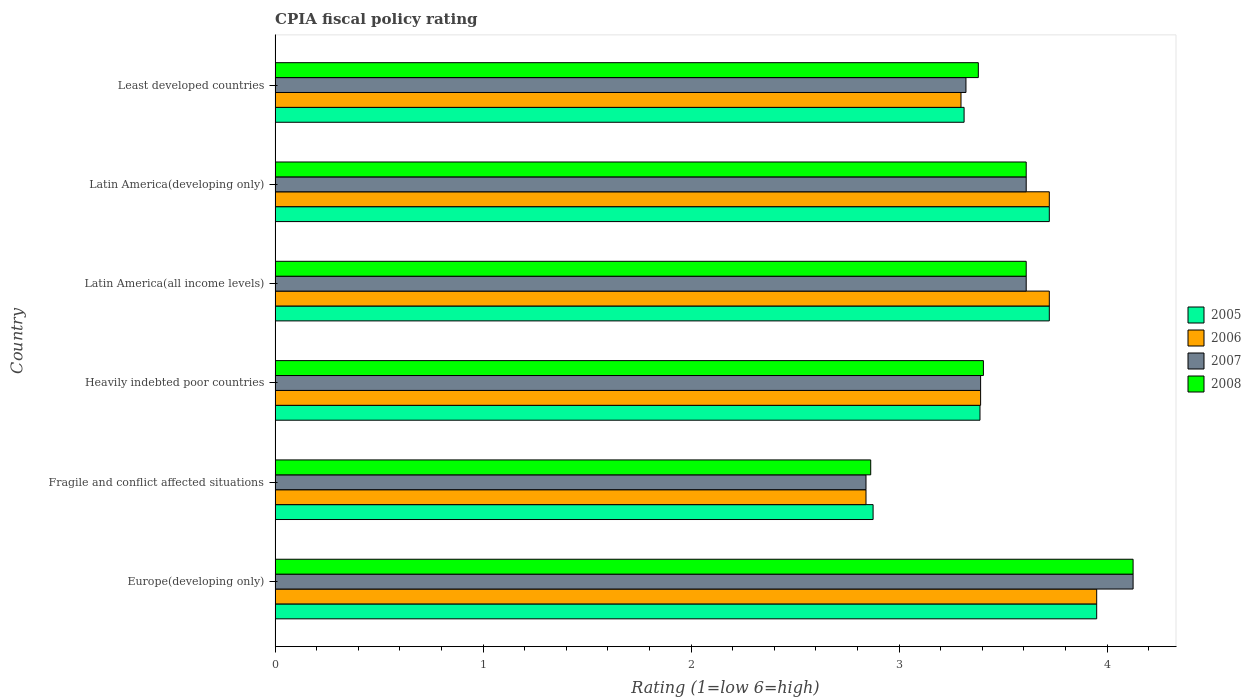How many different coloured bars are there?
Make the answer very short. 4. How many groups of bars are there?
Keep it short and to the point. 6. How many bars are there on the 3rd tick from the top?
Your response must be concise. 4. How many bars are there on the 5th tick from the bottom?
Ensure brevity in your answer.  4. What is the label of the 1st group of bars from the top?
Provide a short and direct response. Least developed countries. What is the CPIA rating in 2007 in Latin America(developing only)?
Ensure brevity in your answer.  3.61. Across all countries, what is the maximum CPIA rating in 2008?
Provide a succinct answer. 4.12. Across all countries, what is the minimum CPIA rating in 2006?
Your answer should be compact. 2.84. In which country was the CPIA rating in 2005 maximum?
Ensure brevity in your answer.  Europe(developing only). In which country was the CPIA rating in 2008 minimum?
Provide a short and direct response. Fragile and conflict affected situations. What is the total CPIA rating in 2005 in the graph?
Give a very brief answer. 20.97. What is the difference between the CPIA rating in 2006 in Latin America(all income levels) and that in Least developed countries?
Your answer should be compact. 0.42. What is the difference between the CPIA rating in 2005 in Heavily indebted poor countries and the CPIA rating in 2006 in Latin America(developing only)?
Provide a short and direct response. -0.33. What is the average CPIA rating in 2007 per country?
Your answer should be compact. 3.48. What is the difference between the CPIA rating in 2008 and CPIA rating in 2007 in Fragile and conflict affected situations?
Make the answer very short. 0.02. What is the ratio of the CPIA rating in 2007 in Europe(developing only) to that in Least developed countries?
Provide a short and direct response. 1.24. Is the difference between the CPIA rating in 2008 in Europe(developing only) and Heavily indebted poor countries greater than the difference between the CPIA rating in 2007 in Europe(developing only) and Heavily indebted poor countries?
Ensure brevity in your answer.  No. What is the difference between the highest and the second highest CPIA rating in 2005?
Keep it short and to the point. 0.23. What is the difference between the highest and the lowest CPIA rating in 2006?
Your response must be concise. 1.11. Is it the case that in every country, the sum of the CPIA rating in 2006 and CPIA rating in 2005 is greater than the CPIA rating in 2008?
Ensure brevity in your answer.  Yes. How many bars are there?
Ensure brevity in your answer.  24. How many countries are there in the graph?
Give a very brief answer. 6. What is the difference between two consecutive major ticks on the X-axis?
Offer a very short reply. 1. Are the values on the major ticks of X-axis written in scientific E-notation?
Offer a very short reply. No. What is the title of the graph?
Offer a terse response. CPIA fiscal policy rating. Does "1997" appear as one of the legend labels in the graph?
Give a very brief answer. No. What is the label or title of the X-axis?
Your answer should be very brief. Rating (1=low 6=high). What is the label or title of the Y-axis?
Provide a succinct answer. Country. What is the Rating (1=low 6=high) of 2005 in Europe(developing only)?
Your answer should be compact. 3.95. What is the Rating (1=low 6=high) in 2006 in Europe(developing only)?
Ensure brevity in your answer.  3.95. What is the Rating (1=low 6=high) of 2007 in Europe(developing only)?
Offer a terse response. 4.12. What is the Rating (1=low 6=high) in 2008 in Europe(developing only)?
Keep it short and to the point. 4.12. What is the Rating (1=low 6=high) of 2005 in Fragile and conflict affected situations?
Provide a succinct answer. 2.88. What is the Rating (1=low 6=high) in 2006 in Fragile and conflict affected situations?
Offer a very short reply. 2.84. What is the Rating (1=low 6=high) of 2007 in Fragile and conflict affected situations?
Offer a terse response. 2.84. What is the Rating (1=low 6=high) in 2008 in Fragile and conflict affected situations?
Provide a succinct answer. 2.86. What is the Rating (1=low 6=high) in 2005 in Heavily indebted poor countries?
Keep it short and to the point. 3.39. What is the Rating (1=low 6=high) in 2006 in Heavily indebted poor countries?
Your response must be concise. 3.39. What is the Rating (1=low 6=high) in 2007 in Heavily indebted poor countries?
Keep it short and to the point. 3.39. What is the Rating (1=low 6=high) in 2008 in Heavily indebted poor countries?
Make the answer very short. 3.41. What is the Rating (1=low 6=high) in 2005 in Latin America(all income levels)?
Your answer should be compact. 3.72. What is the Rating (1=low 6=high) in 2006 in Latin America(all income levels)?
Ensure brevity in your answer.  3.72. What is the Rating (1=low 6=high) in 2007 in Latin America(all income levels)?
Make the answer very short. 3.61. What is the Rating (1=low 6=high) in 2008 in Latin America(all income levels)?
Offer a terse response. 3.61. What is the Rating (1=low 6=high) in 2005 in Latin America(developing only)?
Keep it short and to the point. 3.72. What is the Rating (1=low 6=high) in 2006 in Latin America(developing only)?
Provide a short and direct response. 3.72. What is the Rating (1=low 6=high) in 2007 in Latin America(developing only)?
Your answer should be very brief. 3.61. What is the Rating (1=low 6=high) in 2008 in Latin America(developing only)?
Your answer should be very brief. 3.61. What is the Rating (1=low 6=high) in 2005 in Least developed countries?
Offer a terse response. 3.31. What is the Rating (1=low 6=high) in 2006 in Least developed countries?
Your answer should be very brief. 3.3. What is the Rating (1=low 6=high) of 2007 in Least developed countries?
Give a very brief answer. 3.32. What is the Rating (1=low 6=high) of 2008 in Least developed countries?
Provide a short and direct response. 3.38. Across all countries, what is the maximum Rating (1=low 6=high) in 2005?
Provide a succinct answer. 3.95. Across all countries, what is the maximum Rating (1=low 6=high) in 2006?
Your answer should be very brief. 3.95. Across all countries, what is the maximum Rating (1=low 6=high) of 2007?
Offer a terse response. 4.12. Across all countries, what is the maximum Rating (1=low 6=high) in 2008?
Keep it short and to the point. 4.12. Across all countries, what is the minimum Rating (1=low 6=high) in 2005?
Give a very brief answer. 2.88. Across all countries, what is the minimum Rating (1=low 6=high) of 2006?
Ensure brevity in your answer.  2.84. Across all countries, what is the minimum Rating (1=low 6=high) in 2007?
Make the answer very short. 2.84. Across all countries, what is the minimum Rating (1=low 6=high) in 2008?
Provide a succinct answer. 2.86. What is the total Rating (1=low 6=high) in 2005 in the graph?
Make the answer very short. 20.97. What is the total Rating (1=low 6=high) in 2006 in the graph?
Make the answer very short. 20.92. What is the total Rating (1=low 6=high) in 2007 in the graph?
Provide a succinct answer. 20.9. What is the total Rating (1=low 6=high) of 2008 in the graph?
Offer a very short reply. 21. What is the difference between the Rating (1=low 6=high) in 2005 in Europe(developing only) and that in Fragile and conflict affected situations?
Your response must be concise. 1.07. What is the difference between the Rating (1=low 6=high) of 2006 in Europe(developing only) and that in Fragile and conflict affected situations?
Your answer should be compact. 1.11. What is the difference between the Rating (1=low 6=high) of 2007 in Europe(developing only) and that in Fragile and conflict affected situations?
Your response must be concise. 1.28. What is the difference between the Rating (1=low 6=high) in 2008 in Europe(developing only) and that in Fragile and conflict affected situations?
Keep it short and to the point. 1.26. What is the difference between the Rating (1=low 6=high) in 2005 in Europe(developing only) and that in Heavily indebted poor countries?
Offer a very short reply. 0.56. What is the difference between the Rating (1=low 6=high) of 2006 in Europe(developing only) and that in Heavily indebted poor countries?
Make the answer very short. 0.56. What is the difference between the Rating (1=low 6=high) of 2007 in Europe(developing only) and that in Heavily indebted poor countries?
Offer a terse response. 0.73. What is the difference between the Rating (1=low 6=high) in 2008 in Europe(developing only) and that in Heavily indebted poor countries?
Ensure brevity in your answer.  0.72. What is the difference between the Rating (1=low 6=high) of 2005 in Europe(developing only) and that in Latin America(all income levels)?
Make the answer very short. 0.23. What is the difference between the Rating (1=low 6=high) in 2006 in Europe(developing only) and that in Latin America(all income levels)?
Offer a very short reply. 0.23. What is the difference between the Rating (1=low 6=high) in 2007 in Europe(developing only) and that in Latin America(all income levels)?
Provide a short and direct response. 0.51. What is the difference between the Rating (1=low 6=high) of 2008 in Europe(developing only) and that in Latin America(all income levels)?
Your answer should be very brief. 0.51. What is the difference between the Rating (1=low 6=high) in 2005 in Europe(developing only) and that in Latin America(developing only)?
Ensure brevity in your answer.  0.23. What is the difference between the Rating (1=low 6=high) in 2006 in Europe(developing only) and that in Latin America(developing only)?
Your response must be concise. 0.23. What is the difference between the Rating (1=low 6=high) of 2007 in Europe(developing only) and that in Latin America(developing only)?
Make the answer very short. 0.51. What is the difference between the Rating (1=low 6=high) in 2008 in Europe(developing only) and that in Latin America(developing only)?
Offer a terse response. 0.51. What is the difference between the Rating (1=low 6=high) of 2005 in Europe(developing only) and that in Least developed countries?
Offer a terse response. 0.64. What is the difference between the Rating (1=low 6=high) of 2006 in Europe(developing only) and that in Least developed countries?
Ensure brevity in your answer.  0.65. What is the difference between the Rating (1=low 6=high) in 2007 in Europe(developing only) and that in Least developed countries?
Your answer should be compact. 0.8. What is the difference between the Rating (1=low 6=high) in 2008 in Europe(developing only) and that in Least developed countries?
Your answer should be compact. 0.74. What is the difference between the Rating (1=low 6=high) in 2005 in Fragile and conflict affected situations and that in Heavily indebted poor countries?
Your response must be concise. -0.51. What is the difference between the Rating (1=low 6=high) in 2006 in Fragile and conflict affected situations and that in Heavily indebted poor countries?
Offer a terse response. -0.55. What is the difference between the Rating (1=low 6=high) in 2007 in Fragile and conflict affected situations and that in Heavily indebted poor countries?
Your answer should be very brief. -0.55. What is the difference between the Rating (1=low 6=high) of 2008 in Fragile and conflict affected situations and that in Heavily indebted poor countries?
Your response must be concise. -0.54. What is the difference between the Rating (1=low 6=high) of 2005 in Fragile and conflict affected situations and that in Latin America(all income levels)?
Your response must be concise. -0.85. What is the difference between the Rating (1=low 6=high) in 2006 in Fragile and conflict affected situations and that in Latin America(all income levels)?
Offer a very short reply. -0.88. What is the difference between the Rating (1=low 6=high) of 2007 in Fragile and conflict affected situations and that in Latin America(all income levels)?
Your answer should be compact. -0.77. What is the difference between the Rating (1=low 6=high) of 2008 in Fragile and conflict affected situations and that in Latin America(all income levels)?
Make the answer very short. -0.75. What is the difference between the Rating (1=low 6=high) of 2005 in Fragile and conflict affected situations and that in Latin America(developing only)?
Offer a terse response. -0.85. What is the difference between the Rating (1=low 6=high) of 2006 in Fragile and conflict affected situations and that in Latin America(developing only)?
Give a very brief answer. -0.88. What is the difference between the Rating (1=low 6=high) of 2007 in Fragile and conflict affected situations and that in Latin America(developing only)?
Provide a succinct answer. -0.77. What is the difference between the Rating (1=low 6=high) of 2008 in Fragile and conflict affected situations and that in Latin America(developing only)?
Ensure brevity in your answer.  -0.75. What is the difference between the Rating (1=low 6=high) of 2005 in Fragile and conflict affected situations and that in Least developed countries?
Give a very brief answer. -0.44. What is the difference between the Rating (1=low 6=high) of 2006 in Fragile and conflict affected situations and that in Least developed countries?
Ensure brevity in your answer.  -0.46. What is the difference between the Rating (1=low 6=high) in 2007 in Fragile and conflict affected situations and that in Least developed countries?
Make the answer very short. -0.48. What is the difference between the Rating (1=low 6=high) in 2008 in Fragile and conflict affected situations and that in Least developed countries?
Give a very brief answer. -0.52. What is the difference between the Rating (1=low 6=high) in 2005 in Heavily indebted poor countries and that in Latin America(all income levels)?
Keep it short and to the point. -0.33. What is the difference between the Rating (1=low 6=high) in 2006 in Heavily indebted poor countries and that in Latin America(all income levels)?
Make the answer very short. -0.33. What is the difference between the Rating (1=low 6=high) of 2007 in Heavily indebted poor countries and that in Latin America(all income levels)?
Keep it short and to the point. -0.22. What is the difference between the Rating (1=low 6=high) in 2008 in Heavily indebted poor countries and that in Latin America(all income levels)?
Offer a terse response. -0.21. What is the difference between the Rating (1=low 6=high) of 2005 in Heavily indebted poor countries and that in Latin America(developing only)?
Ensure brevity in your answer.  -0.33. What is the difference between the Rating (1=low 6=high) in 2006 in Heavily indebted poor countries and that in Latin America(developing only)?
Give a very brief answer. -0.33. What is the difference between the Rating (1=low 6=high) in 2007 in Heavily indebted poor countries and that in Latin America(developing only)?
Provide a succinct answer. -0.22. What is the difference between the Rating (1=low 6=high) in 2008 in Heavily indebted poor countries and that in Latin America(developing only)?
Provide a succinct answer. -0.21. What is the difference between the Rating (1=low 6=high) in 2005 in Heavily indebted poor countries and that in Least developed countries?
Your response must be concise. 0.08. What is the difference between the Rating (1=low 6=high) in 2006 in Heavily indebted poor countries and that in Least developed countries?
Keep it short and to the point. 0.09. What is the difference between the Rating (1=low 6=high) of 2007 in Heavily indebted poor countries and that in Least developed countries?
Offer a very short reply. 0.07. What is the difference between the Rating (1=low 6=high) in 2008 in Heavily indebted poor countries and that in Least developed countries?
Your answer should be compact. 0.02. What is the difference between the Rating (1=low 6=high) of 2006 in Latin America(all income levels) and that in Latin America(developing only)?
Offer a very short reply. 0. What is the difference between the Rating (1=low 6=high) in 2007 in Latin America(all income levels) and that in Latin America(developing only)?
Ensure brevity in your answer.  0. What is the difference between the Rating (1=low 6=high) in 2008 in Latin America(all income levels) and that in Latin America(developing only)?
Make the answer very short. 0. What is the difference between the Rating (1=low 6=high) of 2005 in Latin America(all income levels) and that in Least developed countries?
Keep it short and to the point. 0.41. What is the difference between the Rating (1=low 6=high) in 2006 in Latin America(all income levels) and that in Least developed countries?
Offer a very short reply. 0.42. What is the difference between the Rating (1=low 6=high) of 2007 in Latin America(all income levels) and that in Least developed countries?
Keep it short and to the point. 0.29. What is the difference between the Rating (1=low 6=high) of 2008 in Latin America(all income levels) and that in Least developed countries?
Keep it short and to the point. 0.23. What is the difference between the Rating (1=low 6=high) of 2005 in Latin America(developing only) and that in Least developed countries?
Give a very brief answer. 0.41. What is the difference between the Rating (1=low 6=high) in 2006 in Latin America(developing only) and that in Least developed countries?
Your response must be concise. 0.42. What is the difference between the Rating (1=low 6=high) of 2007 in Latin America(developing only) and that in Least developed countries?
Ensure brevity in your answer.  0.29. What is the difference between the Rating (1=low 6=high) of 2008 in Latin America(developing only) and that in Least developed countries?
Your answer should be very brief. 0.23. What is the difference between the Rating (1=low 6=high) of 2005 in Europe(developing only) and the Rating (1=low 6=high) of 2006 in Fragile and conflict affected situations?
Your response must be concise. 1.11. What is the difference between the Rating (1=low 6=high) of 2005 in Europe(developing only) and the Rating (1=low 6=high) of 2007 in Fragile and conflict affected situations?
Your answer should be compact. 1.11. What is the difference between the Rating (1=low 6=high) in 2005 in Europe(developing only) and the Rating (1=low 6=high) in 2008 in Fragile and conflict affected situations?
Ensure brevity in your answer.  1.09. What is the difference between the Rating (1=low 6=high) in 2006 in Europe(developing only) and the Rating (1=low 6=high) in 2007 in Fragile and conflict affected situations?
Provide a succinct answer. 1.11. What is the difference between the Rating (1=low 6=high) of 2006 in Europe(developing only) and the Rating (1=low 6=high) of 2008 in Fragile and conflict affected situations?
Your answer should be compact. 1.09. What is the difference between the Rating (1=low 6=high) of 2007 in Europe(developing only) and the Rating (1=low 6=high) of 2008 in Fragile and conflict affected situations?
Offer a terse response. 1.26. What is the difference between the Rating (1=low 6=high) in 2005 in Europe(developing only) and the Rating (1=low 6=high) in 2006 in Heavily indebted poor countries?
Your answer should be compact. 0.56. What is the difference between the Rating (1=low 6=high) in 2005 in Europe(developing only) and the Rating (1=low 6=high) in 2007 in Heavily indebted poor countries?
Give a very brief answer. 0.56. What is the difference between the Rating (1=low 6=high) in 2005 in Europe(developing only) and the Rating (1=low 6=high) in 2008 in Heavily indebted poor countries?
Keep it short and to the point. 0.54. What is the difference between the Rating (1=low 6=high) of 2006 in Europe(developing only) and the Rating (1=low 6=high) of 2007 in Heavily indebted poor countries?
Make the answer very short. 0.56. What is the difference between the Rating (1=low 6=high) in 2006 in Europe(developing only) and the Rating (1=low 6=high) in 2008 in Heavily indebted poor countries?
Your answer should be very brief. 0.54. What is the difference between the Rating (1=low 6=high) of 2007 in Europe(developing only) and the Rating (1=low 6=high) of 2008 in Heavily indebted poor countries?
Make the answer very short. 0.72. What is the difference between the Rating (1=low 6=high) in 2005 in Europe(developing only) and the Rating (1=low 6=high) in 2006 in Latin America(all income levels)?
Your response must be concise. 0.23. What is the difference between the Rating (1=low 6=high) of 2005 in Europe(developing only) and the Rating (1=low 6=high) of 2007 in Latin America(all income levels)?
Your answer should be very brief. 0.34. What is the difference between the Rating (1=low 6=high) of 2005 in Europe(developing only) and the Rating (1=low 6=high) of 2008 in Latin America(all income levels)?
Provide a short and direct response. 0.34. What is the difference between the Rating (1=low 6=high) in 2006 in Europe(developing only) and the Rating (1=low 6=high) in 2007 in Latin America(all income levels)?
Give a very brief answer. 0.34. What is the difference between the Rating (1=low 6=high) of 2006 in Europe(developing only) and the Rating (1=low 6=high) of 2008 in Latin America(all income levels)?
Keep it short and to the point. 0.34. What is the difference between the Rating (1=low 6=high) of 2007 in Europe(developing only) and the Rating (1=low 6=high) of 2008 in Latin America(all income levels)?
Offer a terse response. 0.51. What is the difference between the Rating (1=low 6=high) of 2005 in Europe(developing only) and the Rating (1=low 6=high) of 2006 in Latin America(developing only)?
Ensure brevity in your answer.  0.23. What is the difference between the Rating (1=low 6=high) in 2005 in Europe(developing only) and the Rating (1=low 6=high) in 2007 in Latin America(developing only)?
Offer a very short reply. 0.34. What is the difference between the Rating (1=low 6=high) in 2005 in Europe(developing only) and the Rating (1=low 6=high) in 2008 in Latin America(developing only)?
Your answer should be compact. 0.34. What is the difference between the Rating (1=low 6=high) of 2006 in Europe(developing only) and the Rating (1=low 6=high) of 2007 in Latin America(developing only)?
Your answer should be very brief. 0.34. What is the difference between the Rating (1=low 6=high) of 2006 in Europe(developing only) and the Rating (1=low 6=high) of 2008 in Latin America(developing only)?
Provide a short and direct response. 0.34. What is the difference between the Rating (1=low 6=high) of 2007 in Europe(developing only) and the Rating (1=low 6=high) of 2008 in Latin America(developing only)?
Your response must be concise. 0.51. What is the difference between the Rating (1=low 6=high) of 2005 in Europe(developing only) and the Rating (1=low 6=high) of 2006 in Least developed countries?
Ensure brevity in your answer.  0.65. What is the difference between the Rating (1=low 6=high) of 2005 in Europe(developing only) and the Rating (1=low 6=high) of 2007 in Least developed countries?
Give a very brief answer. 0.63. What is the difference between the Rating (1=low 6=high) in 2005 in Europe(developing only) and the Rating (1=low 6=high) in 2008 in Least developed countries?
Ensure brevity in your answer.  0.57. What is the difference between the Rating (1=low 6=high) in 2006 in Europe(developing only) and the Rating (1=low 6=high) in 2007 in Least developed countries?
Your answer should be very brief. 0.63. What is the difference between the Rating (1=low 6=high) in 2006 in Europe(developing only) and the Rating (1=low 6=high) in 2008 in Least developed countries?
Your answer should be very brief. 0.57. What is the difference between the Rating (1=low 6=high) in 2007 in Europe(developing only) and the Rating (1=low 6=high) in 2008 in Least developed countries?
Offer a terse response. 0.74. What is the difference between the Rating (1=low 6=high) of 2005 in Fragile and conflict affected situations and the Rating (1=low 6=high) of 2006 in Heavily indebted poor countries?
Make the answer very short. -0.52. What is the difference between the Rating (1=low 6=high) of 2005 in Fragile and conflict affected situations and the Rating (1=low 6=high) of 2007 in Heavily indebted poor countries?
Provide a short and direct response. -0.52. What is the difference between the Rating (1=low 6=high) in 2005 in Fragile and conflict affected situations and the Rating (1=low 6=high) in 2008 in Heavily indebted poor countries?
Make the answer very short. -0.53. What is the difference between the Rating (1=low 6=high) in 2006 in Fragile and conflict affected situations and the Rating (1=low 6=high) in 2007 in Heavily indebted poor countries?
Offer a very short reply. -0.55. What is the difference between the Rating (1=low 6=high) in 2006 in Fragile and conflict affected situations and the Rating (1=low 6=high) in 2008 in Heavily indebted poor countries?
Make the answer very short. -0.56. What is the difference between the Rating (1=low 6=high) of 2007 in Fragile and conflict affected situations and the Rating (1=low 6=high) of 2008 in Heavily indebted poor countries?
Ensure brevity in your answer.  -0.56. What is the difference between the Rating (1=low 6=high) of 2005 in Fragile and conflict affected situations and the Rating (1=low 6=high) of 2006 in Latin America(all income levels)?
Provide a short and direct response. -0.85. What is the difference between the Rating (1=low 6=high) in 2005 in Fragile and conflict affected situations and the Rating (1=low 6=high) in 2007 in Latin America(all income levels)?
Offer a very short reply. -0.74. What is the difference between the Rating (1=low 6=high) in 2005 in Fragile and conflict affected situations and the Rating (1=low 6=high) in 2008 in Latin America(all income levels)?
Your answer should be compact. -0.74. What is the difference between the Rating (1=low 6=high) of 2006 in Fragile and conflict affected situations and the Rating (1=low 6=high) of 2007 in Latin America(all income levels)?
Give a very brief answer. -0.77. What is the difference between the Rating (1=low 6=high) of 2006 in Fragile and conflict affected situations and the Rating (1=low 6=high) of 2008 in Latin America(all income levels)?
Offer a very short reply. -0.77. What is the difference between the Rating (1=low 6=high) in 2007 in Fragile and conflict affected situations and the Rating (1=low 6=high) in 2008 in Latin America(all income levels)?
Keep it short and to the point. -0.77. What is the difference between the Rating (1=low 6=high) of 2005 in Fragile and conflict affected situations and the Rating (1=low 6=high) of 2006 in Latin America(developing only)?
Keep it short and to the point. -0.85. What is the difference between the Rating (1=low 6=high) in 2005 in Fragile and conflict affected situations and the Rating (1=low 6=high) in 2007 in Latin America(developing only)?
Your answer should be very brief. -0.74. What is the difference between the Rating (1=low 6=high) in 2005 in Fragile and conflict affected situations and the Rating (1=low 6=high) in 2008 in Latin America(developing only)?
Your answer should be very brief. -0.74. What is the difference between the Rating (1=low 6=high) of 2006 in Fragile and conflict affected situations and the Rating (1=low 6=high) of 2007 in Latin America(developing only)?
Offer a very short reply. -0.77. What is the difference between the Rating (1=low 6=high) in 2006 in Fragile and conflict affected situations and the Rating (1=low 6=high) in 2008 in Latin America(developing only)?
Provide a succinct answer. -0.77. What is the difference between the Rating (1=low 6=high) of 2007 in Fragile and conflict affected situations and the Rating (1=low 6=high) of 2008 in Latin America(developing only)?
Provide a succinct answer. -0.77. What is the difference between the Rating (1=low 6=high) in 2005 in Fragile and conflict affected situations and the Rating (1=low 6=high) in 2006 in Least developed countries?
Provide a short and direct response. -0.42. What is the difference between the Rating (1=low 6=high) in 2005 in Fragile and conflict affected situations and the Rating (1=low 6=high) in 2007 in Least developed countries?
Make the answer very short. -0.45. What is the difference between the Rating (1=low 6=high) in 2005 in Fragile and conflict affected situations and the Rating (1=low 6=high) in 2008 in Least developed countries?
Keep it short and to the point. -0.51. What is the difference between the Rating (1=low 6=high) in 2006 in Fragile and conflict affected situations and the Rating (1=low 6=high) in 2007 in Least developed countries?
Give a very brief answer. -0.48. What is the difference between the Rating (1=low 6=high) of 2006 in Fragile and conflict affected situations and the Rating (1=low 6=high) of 2008 in Least developed countries?
Provide a succinct answer. -0.54. What is the difference between the Rating (1=low 6=high) of 2007 in Fragile and conflict affected situations and the Rating (1=low 6=high) of 2008 in Least developed countries?
Your response must be concise. -0.54. What is the difference between the Rating (1=low 6=high) of 2005 in Heavily indebted poor countries and the Rating (1=low 6=high) of 2006 in Latin America(all income levels)?
Offer a terse response. -0.33. What is the difference between the Rating (1=low 6=high) of 2005 in Heavily indebted poor countries and the Rating (1=low 6=high) of 2007 in Latin America(all income levels)?
Your answer should be very brief. -0.22. What is the difference between the Rating (1=low 6=high) of 2005 in Heavily indebted poor countries and the Rating (1=low 6=high) of 2008 in Latin America(all income levels)?
Provide a succinct answer. -0.22. What is the difference between the Rating (1=low 6=high) of 2006 in Heavily indebted poor countries and the Rating (1=low 6=high) of 2007 in Latin America(all income levels)?
Your answer should be very brief. -0.22. What is the difference between the Rating (1=low 6=high) in 2006 in Heavily indebted poor countries and the Rating (1=low 6=high) in 2008 in Latin America(all income levels)?
Keep it short and to the point. -0.22. What is the difference between the Rating (1=low 6=high) of 2007 in Heavily indebted poor countries and the Rating (1=low 6=high) of 2008 in Latin America(all income levels)?
Make the answer very short. -0.22. What is the difference between the Rating (1=low 6=high) in 2005 in Heavily indebted poor countries and the Rating (1=low 6=high) in 2007 in Latin America(developing only)?
Make the answer very short. -0.22. What is the difference between the Rating (1=low 6=high) of 2005 in Heavily indebted poor countries and the Rating (1=low 6=high) of 2008 in Latin America(developing only)?
Your response must be concise. -0.22. What is the difference between the Rating (1=low 6=high) in 2006 in Heavily indebted poor countries and the Rating (1=low 6=high) in 2007 in Latin America(developing only)?
Your answer should be compact. -0.22. What is the difference between the Rating (1=low 6=high) in 2006 in Heavily indebted poor countries and the Rating (1=low 6=high) in 2008 in Latin America(developing only)?
Keep it short and to the point. -0.22. What is the difference between the Rating (1=low 6=high) of 2007 in Heavily indebted poor countries and the Rating (1=low 6=high) of 2008 in Latin America(developing only)?
Give a very brief answer. -0.22. What is the difference between the Rating (1=low 6=high) of 2005 in Heavily indebted poor countries and the Rating (1=low 6=high) of 2006 in Least developed countries?
Ensure brevity in your answer.  0.09. What is the difference between the Rating (1=low 6=high) in 2005 in Heavily indebted poor countries and the Rating (1=low 6=high) in 2007 in Least developed countries?
Your answer should be compact. 0.07. What is the difference between the Rating (1=low 6=high) in 2005 in Heavily indebted poor countries and the Rating (1=low 6=high) in 2008 in Least developed countries?
Offer a terse response. 0.01. What is the difference between the Rating (1=low 6=high) in 2006 in Heavily indebted poor countries and the Rating (1=low 6=high) in 2007 in Least developed countries?
Offer a very short reply. 0.07. What is the difference between the Rating (1=low 6=high) in 2006 in Heavily indebted poor countries and the Rating (1=low 6=high) in 2008 in Least developed countries?
Your answer should be compact. 0.01. What is the difference between the Rating (1=low 6=high) of 2007 in Heavily indebted poor countries and the Rating (1=low 6=high) of 2008 in Least developed countries?
Keep it short and to the point. 0.01. What is the difference between the Rating (1=low 6=high) in 2005 in Latin America(all income levels) and the Rating (1=low 6=high) in 2006 in Latin America(developing only)?
Keep it short and to the point. 0. What is the difference between the Rating (1=low 6=high) in 2006 in Latin America(all income levels) and the Rating (1=low 6=high) in 2007 in Latin America(developing only)?
Provide a succinct answer. 0.11. What is the difference between the Rating (1=low 6=high) of 2007 in Latin America(all income levels) and the Rating (1=low 6=high) of 2008 in Latin America(developing only)?
Your answer should be compact. 0. What is the difference between the Rating (1=low 6=high) in 2005 in Latin America(all income levels) and the Rating (1=low 6=high) in 2006 in Least developed countries?
Offer a very short reply. 0.42. What is the difference between the Rating (1=low 6=high) of 2005 in Latin America(all income levels) and the Rating (1=low 6=high) of 2007 in Least developed countries?
Your answer should be compact. 0.4. What is the difference between the Rating (1=low 6=high) in 2005 in Latin America(all income levels) and the Rating (1=low 6=high) in 2008 in Least developed countries?
Provide a succinct answer. 0.34. What is the difference between the Rating (1=low 6=high) in 2006 in Latin America(all income levels) and the Rating (1=low 6=high) in 2007 in Least developed countries?
Offer a terse response. 0.4. What is the difference between the Rating (1=low 6=high) of 2006 in Latin America(all income levels) and the Rating (1=low 6=high) of 2008 in Least developed countries?
Keep it short and to the point. 0.34. What is the difference between the Rating (1=low 6=high) in 2007 in Latin America(all income levels) and the Rating (1=low 6=high) in 2008 in Least developed countries?
Give a very brief answer. 0.23. What is the difference between the Rating (1=low 6=high) of 2005 in Latin America(developing only) and the Rating (1=low 6=high) of 2006 in Least developed countries?
Provide a short and direct response. 0.42. What is the difference between the Rating (1=low 6=high) in 2005 in Latin America(developing only) and the Rating (1=low 6=high) in 2007 in Least developed countries?
Provide a short and direct response. 0.4. What is the difference between the Rating (1=low 6=high) of 2005 in Latin America(developing only) and the Rating (1=low 6=high) of 2008 in Least developed countries?
Make the answer very short. 0.34. What is the difference between the Rating (1=low 6=high) in 2006 in Latin America(developing only) and the Rating (1=low 6=high) in 2007 in Least developed countries?
Provide a succinct answer. 0.4. What is the difference between the Rating (1=low 6=high) in 2006 in Latin America(developing only) and the Rating (1=low 6=high) in 2008 in Least developed countries?
Make the answer very short. 0.34. What is the difference between the Rating (1=low 6=high) in 2007 in Latin America(developing only) and the Rating (1=low 6=high) in 2008 in Least developed countries?
Your answer should be compact. 0.23. What is the average Rating (1=low 6=high) of 2005 per country?
Your answer should be very brief. 3.5. What is the average Rating (1=low 6=high) in 2006 per country?
Keep it short and to the point. 3.49. What is the average Rating (1=low 6=high) of 2007 per country?
Give a very brief answer. 3.48. What is the average Rating (1=low 6=high) in 2008 per country?
Offer a terse response. 3.5. What is the difference between the Rating (1=low 6=high) of 2005 and Rating (1=low 6=high) of 2006 in Europe(developing only)?
Offer a very short reply. 0. What is the difference between the Rating (1=low 6=high) in 2005 and Rating (1=low 6=high) in 2007 in Europe(developing only)?
Ensure brevity in your answer.  -0.17. What is the difference between the Rating (1=low 6=high) of 2005 and Rating (1=low 6=high) of 2008 in Europe(developing only)?
Your response must be concise. -0.17. What is the difference between the Rating (1=low 6=high) in 2006 and Rating (1=low 6=high) in 2007 in Europe(developing only)?
Provide a short and direct response. -0.17. What is the difference between the Rating (1=low 6=high) in 2006 and Rating (1=low 6=high) in 2008 in Europe(developing only)?
Offer a terse response. -0.17. What is the difference between the Rating (1=low 6=high) in 2005 and Rating (1=low 6=high) in 2006 in Fragile and conflict affected situations?
Make the answer very short. 0.03. What is the difference between the Rating (1=low 6=high) of 2005 and Rating (1=low 6=high) of 2007 in Fragile and conflict affected situations?
Offer a terse response. 0.03. What is the difference between the Rating (1=low 6=high) of 2005 and Rating (1=low 6=high) of 2008 in Fragile and conflict affected situations?
Keep it short and to the point. 0.01. What is the difference between the Rating (1=low 6=high) of 2006 and Rating (1=low 6=high) of 2007 in Fragile and conflict affected situations?
Give a very brief answer. 0. What is the difference between the Rating (1=low 6=high) in 2006 and Rating (1=low 6=high) in 2008 in Fragile and conflict affected situations?
Provide a short and direct response. -0.02. What is the difference between the Rating (1=low 6=high) in 2007 and Rating (1=low 6=high) in 2008 in Fragile and conflict affected situations?
Ensure brevity in your answer.  -0.02. What is the difference between the Rating (1=low 6=high) of 2005 and Rating (1=low 6=high) of 2006 in Heavily indebted poor countries?
Your answer should be very brief. -0. What is the difference between the Rating (1=low 6=high) of 2005 and Rating (1=low 6=high) of 2007 in Heavily indebted poor countries?
Offer a terse response. -0. What is the difference between the Rating (1=low 6=high) of 2005 and Rating (1=low 6=high) of 2008 in Heavily indebted poor countries?
Ensure brevity in your answer.  -0.02. What is the difference between the Rating (1=low 6=high) in 2006 and Rating (1=low 6=high) in 2008 in Heavily indebted poor countries?
Give a very brief answer. -0.01. What is the difference between the Rating (1=low 6=high) of 2007 and Rating (1=low 6=high) of 2008 in Heavily indebted poor countries?
Keep it short and to the point. -0.01. What is the difference between the Rating (1=low 6=high) in 2005 and Rating (1=low 6=high) in 2006 in Latin America(all income levels)?
Offer a very short reply. 0. What is the difference between the Rating (1=low 6=high) of 2005 and Rating (1=low 6=high) of 2008 in Latin America(all income levels)?
Your response must be concise. 0.11. What is the difference between the Rating (1=low 6=high) in 2006 and Rating (1=low 6=high) in 2007 in Latin America(all income levels)?
Offer a terse response. 0.11. What is the difference between the Rating (1=low 6=high) in 2007 and Rating (1=low 6=high) in 2008 in Latin America(all income levels)?
Offer a very short reply. 0. What is the difference between the Rating (1=low 6=high) in 2005 and Rating (1=low 6=high) in 2007 in Latin America(developing only)?
Make the answer very short. 0.11. What is the difference between the Rating (1=low 6=high) of 2005 and Rating (1=low 6=high) of 2008 in Latin America(developing only)?
Offer a terse response. 0.11. What is the difference between the Rating (1=low 6=high) in 2006 and Rating (1=low 6=high) in 2007 in Latin America(developing only)?
Offer a terse response. 0.11. What is the difference between the Rating (1=low 6=high) of 2007 and Rating (1=low 6=high) of 2008 in Latin America(developing only)?
Provide a short and direct response. 0. What is the difference between the Rating (1=low 6=high) of 2005 and Rating (1=low 6=high) of 2006 in Least developed countries?
Offer a very short reply. 0.01. What is the difference between the Rating (1=low 6=high) of 2005 and Rating (1=low 6=high) of 2007 in Least developed countries?
Ensure brevity in your answer.  -0.01. What is the difference between the Rating (1=low 6=high) of 2005 and Rating (1=low 6=high) of 2008 in Least developed countries?
Keep it short and to the point. -0.07. What is the difference between the Rating (1=low 6=high) in 2006 and Rating (1=low 6=high) in 2007 in Least developed countries?
Keep it short and to the point. -0.02. What is the difference between the Rating (1=low 6=high) of 2006 and Rating (1=low 6=high) of 2008 in Least developed countries?
Your response must be concise. -0.08. What is the difference between the Rating (1=low 6=high) of 2007 and Rating (1=low 6=high) of 2008 in Least developed countries?
Make the answer very short. -0.06. What is the ratio of the Rating (1=low 6=high) in 2005 in Europe(developing only) to that in Fragile and conflict affected situations?
Your answer should be very brief. 1.37. What is the ratio of the Rating (1=low 6=high) in 2006 in Europe(developing only) to that in Fragile and conflict affected situations?
Your answer should be very brief. 1.39. What is the ratio of the Rating (1=low 6=high) in 2007 in Europe(developing only) to that in Fragile and conflict affected situations?
Your response must be concise. 1.45. What is the ratio of the Rating (1=low 6=high) in 2008 in Europe(developing only) to that in Fragile and conflict affected situations?
Make the answer very short. 1.44. What is the ratio of the Rating (1=low 6=high) of 2005 in Europe(developing only) to that in Heavily indebted poor countries?
Offer a terse response. 1.17. What is the ratio of the Rating (1=low 6=high) of 2006 in Europe(developing only) to that in Heavily indebted poor countries?
Provide a succinct answer. 1.16. What is the ratio of the Rating (1=low 6=high) of 2007 in Europe(developing only) to that in Heavily indebted poor countries?
Your response must be concise. 1.22. What is the ratio of the Rating (1=low 6=high) of 2008 in Europe(developing only) to that in Heavily indebted poor countries?
Your answer should be very brief. 1.21. What is the ratio of the Rating (1=low 6=high) in 2005 in Europe(developing only) to that in Latin America(all income levels)?
Your answer should be compact. 1.06. What is the ratio of the Rating (1=low 6=high) in 2006 in Europe(developing only) to that in Latin America(all income levels)?
Provide a succinct answer. 1.06. What is the ratio of the Rating (1=low 6=high) in 2007 in Europe(developing only) to that in Latin America(all income levels)?
Your answer should be compact. 1.14. What is the ratio of the Rating (1=low 6=high) of 2008 in Europe(developing only) to that in Latin America(all income levels)?
Ensure brevity in your answer.  1.14. What is the ratio of the Rating (1=low 6=high) in 2005 in Europe(developing only) to that in Latin America(developing only)?
Your answer should be very brief. 1.06. What is the ratio of the Rating (1=low 6=high) of 2006 in Europe(developing only) to that in Latin America(developing only)?
Give a very brief answer. 1.06. What is the ratio of the Rating (1=low 6=high) of 2007 in Europe(developing only) to that in Latin America(developing only)?
Your answer should be very brief. 1.14. What is the ratio of the Rating (1=low 6=high) in 2008 in Europe(developing only) to that in Latin America(developing only)?
Provide a short and direct response. 1.14. What is the ratio of the Rating (1=low 6=high) of 2005 in Europe(developing only) to that in Least developed countries?
Provide a short and direct response. 1.19. What is the ratio of the Rating (1=low 6=high) of 2006 in Europe(developing only) to that in Least developed countries?
Give a very brief answer. 1.2. What is the ratio of the Rating (1=low 6=high) in 2007 in Europe(developing only) to that in Least developed countries?
Provide a succinct answer. 1.24. What is the ratio of the Rating (1=low 6=high) of 2008 in Europe(developing only) to that in Least developed countries?
Provide a short and direct response. 1.22. What is the ratio of the Rating (1=low 6=high) in 2005 in Fragile and conflict affected situations to that in Heavily indebted poor countries?
Keep it short and to the point. 0.85. What is the ratio of the Rating (1=low 6=high) in 2006 in Fragile and conflict affected situations to that in Heavily indebted poor countries?
Make the answer very short. 0.84. What is the ratio of the Rating (1=low 6=high) of 2007 in Fragile and conflict affected situations to that in Heavily indebted poor countries?
Make the answer very short. 0.84. What is the ratio of the Rating (1=low 6=high) of 2008 in Fragile and conflict affected situations to that in Heavily indebted poor countries?
Offer a terse response. 0.84. What is the ratio of the Rating (1=low 6=high) in 2005 in Fragile and conflict affected situations to that in Latin America(all income levels)?
Provide a short and direct response. 0.77. What is the ratio of the Rating (1=low 6=high) in 2006 in Fragile and conflict affected situations to that in Latin America(all income levels)?
Provide a short and direct response. 0.76. What is the ratio of the Rating (1=low 6=high) in 2007 in Fragile and conflict affected situations to that in Latin America(all income levels)?
Your answer should be very brief. 0.79. What is the ratio of the Rating (1=low 6=high) in 2008 in Fragile and conflict affected situations to that in Latin America(all income levels)?
Provide a short and direct response. 0.79. What is the ratio of the Rating (1=low 6=high) of 2005 in Fragile and conflict affected situations to that in Latin America(developing only)?
Make the answer very short. 0.77. What is the ratio of the Rating (1=low 6=high) of 2006 in Fragile and conflict affected situations to that in Latin America(developing only)?
Offer a terse response. 0.76. What is the ratio of the Rating (1=low 6=high) of 2007 in Fragile and conflict affected situations to that in Latin America(developing only)?
Ensure brevity in your answer.  0.79. What is the ratio of the Rating (1=low 6=high) in 2008 in Fragile and conflict affected situations to that in Latin America(developing only)?
Your answer should be very brief. 0.79. What is the ratio of the Rating (1=low 6=high) of 2005 in Fragile and conflict affected situations to that in Least developed countries?
Offer a terse response. 0.87. What is the ratio of the Rating (1=low 6=high) in 2006 in Fragile and conflict affected situations to that in Least developed countries?
Ensure brevity in your answer.  0.86. What is the ratio of the Rating (1=low 6=high) in 2007 in Fragile and conflict affected situations to that in Least developed countries?
Offer a terse response. 0.86. What is the ratio of the Rating (1=low 6=high) of 2008 in Fragile and conflict affected situations to that in Least developed countries?
Your response must be concise. 0.85. What is the ratio of the Rating (1=low 6=high) in 2005 in Heavily indebted poor countries to that in Latin America(all income levels)?
Give a very brief answer. 0.91. What is the ratio of the Rating (1=low 6=high) of 2006 in Heavily indebted poor countries to that in Latin America(all income levels)?
Ensure brevity in your answer.  0.91. What is the ratio of the Rating (1=low 6=high) of 2007 in Heavily indebted poor countries to that in Latin America(all income levels)?
Make the answer very short. 0.94. What is the ratio of the Rating (1=low 6=high) in 2008 in Heavily indebted poor countries to that in Latin America(all income levels)?
Make the answer very short. 0.94. What is the ratio of the Rating (1=low 6=high) of 2005 in Heavily indebted poor countries to that in Latin America(developing only)?
Keep it short and to the point. 0.91. What is the ratio of the Rating (1=low 6=high) in 2006 in Heavily indebted poor countries to that in Latin America(developing only)?
Provide a short and direct response. 0.91. What is the ratio of the Rating (1=low 6=high) of 2007 in Heavily indebted poor countries to that in Latin America(developing only)?
Give a very brief answer. 0.94. What is the ratio of the Rating (1=low 6=high) of 2008 in Heavily indebted poor countries to that in Latin America(developing only)?
Your answer should be compact. 0.94. What is the ratio of the Rating (1=low 6=high) of 2005 in Heavily indebted poor countries to that in Least developed countries?
Ensure brevity in your answer.  1.02. What is the ratio of the Rating (1=low 6=high) in 2006 in Heavily indebted poor countries to that in Least developed countries?
Offer a very short reply. 1.03. What is the ratio of the Rating (1=low 6=high) of 2007 in Heavily indebted poor countries to that in Least developed countries?
Your response must be concise. 1.02. What is the ratio of the Rating (1=low 6=high) in 2008 in Heavily indebted poor countries to that in Least developed countries?
Provide a succinct answer. 1.01. What is the ratio of the Rating (1=low 6=high) of 2008 in Latin America(all income levels) to that in Latin America(developing only)?
Offer a very short reply. 1. What is the ratio of the Rating (1=low 6=high) of 2005 in Latin America(all income levels) to that in Least developed countries?
Make the answer very short. 1.12. What is the ratio of the Rating (1=low 6=high) of 2006 in Latin America(all income levels) to that in Least developed countries?
Give a very brief answer. 1.13. What is the ratio of the Rating (1=low 6=high) of 2007 in Latin America(all income levels) to that in Least developed countries?
Your answer should be compact. 1.09. What is the ratio of the Rating (1=low 6=high) of 2008 in Latin America(all income levels) to that in Least developed countries?
Your response must be concise. 1.07. What is the ratio of the Rating (1=low 6=high) of 2005 in Latin America(developing only) to that in Least developed countries?
Keep it short and to the point. 1.12. What is the ratio of the Rating (1=low 6=high) in 2006 in Latin America(developing only) to that in Least developed countries?
Provide a succinct answer. 1.13. What is the ratio of the Rating (1=low 6=high) in 2007 in Latin America(developing only) to that in Least developed countries?
Provide a short and direct response. 1.09. What is the ratio of the Rating (1=low 6=high) of 2008 in Latin America(developing only) to that in Least developed countries?
Give a very brief answer. 1.07. What is the difference between the highest and the second highest Rating (1=low 6=high) of 2005?
Offer a terse response. 0.23. What is the difference between the highest and the second highest Rating (1=low 6=high) of 2006?
Offer a terse response. 0.23. What is the difference between the highest and the second highest Rating (1=low 6=high) of 2007?
Give a very brief answer. 0.51. What is the difference between the highest and the second highest Rating (1=low 6=high) in 2008?
Provide a succinct answer. 0.51. What is the difference between the highest and the lowest Rating (1=low 6=high) of 2005?
Your response must be concise. 1.07. What is the difference between the highest and the lowest Rating (1=low 6=high) of 2006?
Offer a very short reply. 1.11. What is the difference between the highest and the lowest Rating (1=low 6=high) in 2007?
Your answer should be very brief. 1.28. What is the difference between the highest and the lowest Rating (1=low 6=high) in 2008?
Your answer should be compact. 1.26. 